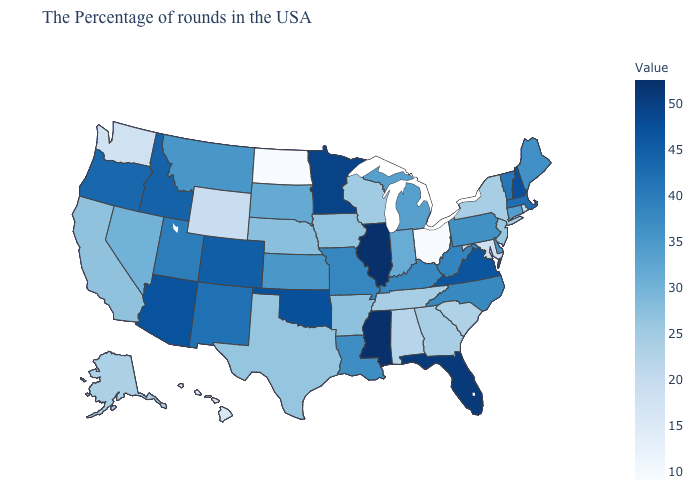Which states have the lowest value in the USA?
Write a very short answer. Ohio, North Dakota. Which states have the lowest value in the USA?
Keep it brief. Ohio, North Dakota. Does Mississippi have the highest value in the USA?
Concise answer only. Yes. Among the states that border Arkansas , which have the lowest value?
Keep it brief. Tennessee. Among the states that border Wisconsin , does Minnesota have the lowest value?
Concise answer only. No. 